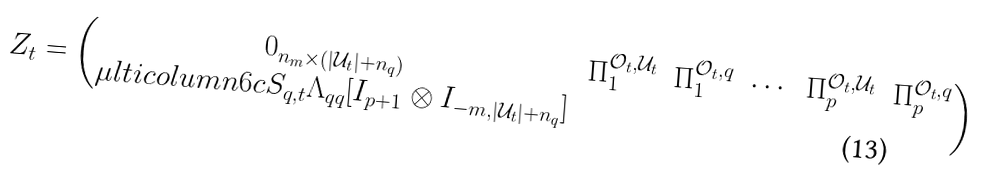Convert formula to latex. <formula><loc_0><loc_0><loc_500><loc_500>Z _ { t } = \begin{pmatrix} 0 _ { n _ { m } \times ( | \mathcal { U } _ { t } | + n _ { q } ) } & \Pi _ { 1 } ^ { \mathcal { O } _ { t } , \mathcal { U } _ { t } } & \Pi _ { 1 } ^ { \mathcal { O } _ { t } , q } & \cdots & \Pi _ { p } ^ { \mathcal { O } _ { t } , \mathcal { U } _ { t } } & \Pi _ { p } ^ { \mathcal { O } _ { t } , q } \\ \mu l t i c o l u m n { 6 } { c } { S _ { q , t } \Lambda _ { q q } [ I _ { p + 1 } \otimes I _ { - m , | \mathcal { U } _ { t } | + n _ { q } } ] } \end{pmatrix}</formula> 